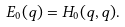Convert formula to latex. <formula><loc_0><loc_0><loc_500><loc_500>E _ { 0 } ( q ) = H _ { 0 } ( q , q ) .</formula> 